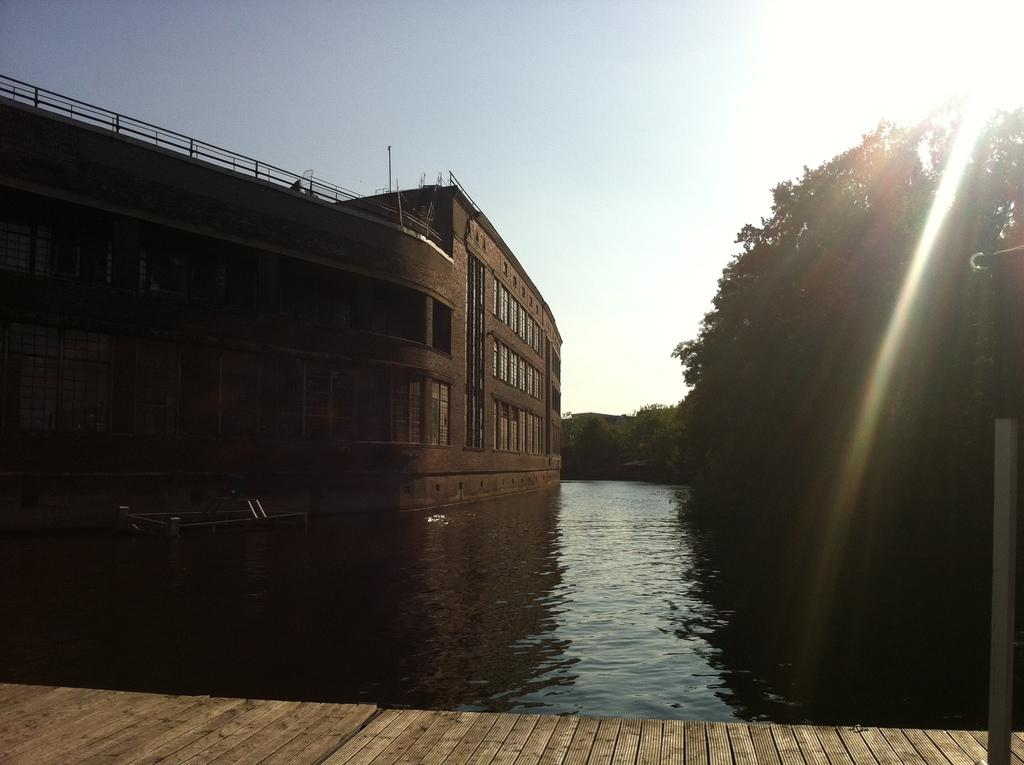What type of structure is present in the image? There is a building in the image. What natural element can be seen in the image? There is water visible in the image. What type of vegetation is present in the image? There are trees in the image. What object is located on the right side of the image? There is a pole on the right side of the image. What is visible in the background of the image? The sky is visible in the background of the image. Where are the dolls playing in the field in the image? There are no dolls or fields present in the image. What type of battle is taking place in the image? There is no battle present in the image. 